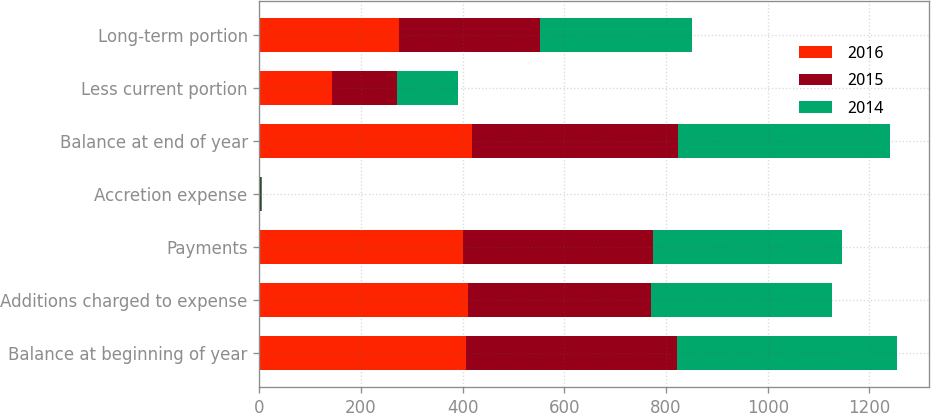<chart> <loc_0><loc_0><loc_500><loc_500><stacked_bar_chart><ecel><fcel>Balance at beginning of year<fcel>Additions charged to expense<fcel>Payments<fcel>Accretion expense<fcel>Balance at end of year<fcel>Less current portion<fcel>Long-term portion<nl><fcel>2016<fcel>405.8<fcel>410.3<fcel>400.5<fcel>1.5<fcel>418.5<fcel>143.9<fcel>274.6<nl><fcel>2015<fcel>416.6<fcel>360.4<fcel>373.1<fcel>1.9<fcel>405.8<fcel>127.7<fcel>278.1<nl><fcel>2014<fcel>431.5<fcel>354.8<fcel>372.2<fcel>2.5<fcel>416.6<fcel>118.6<fcel>298<nl></chart> 